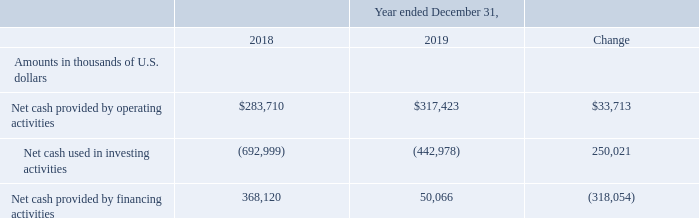Cash Flows
Year ended December 31, 2018 compared to the year ended December 31, 2019
The following table summarizes our net cash flows from operating, investing and financing activities for the years indicated:
Net Cash Provided By Operating Activities
Net cash provided by operating activities increased by $33.7 million, from $283.7 million during the year ended December 31, 2018 to $317.4 million during the year ended December 31, 2019. The increase was attributable to an increase of $57.7 million caused by movements in working capital accounts due primarily to (a) increased cash from related parties of $56.3 million (mainly collection of Cool Pool receivables), (b) an increase of $20.3 million from movements in other payables and accruals, and (c) an increase of $4.6 million from movements in trade and other receivables, partially offset by an increase in cash collateral on swaps of $22.2 million, an increase of $28.2 million in total revenues (revenues and net pool allocation), partially offset by a decrease of $29.9 million in cash paid for interest including the interest paid for finance leases and a net decrease of $22.3 million from the remaining movements.
Net Cash Used In Investing Activities
Net cash used in investing activities decreased by $250.0 million, from $693.0 million during the year ended December 31, 2018 to $443.0 million during the year ended December 31, 2019. The decrease is attributable to a decrease of $203.7 million in net cash used in payments for the construction costs of newbuildings and other fixed assets, a net increase of $45.5 million in cash from short-term investments in the year ended December 31, 2019, compared to the same period of 2018 and an increase of $0.8 million in cash from interest income.
Net Cash Provided By Financing Activities
Net cash provided by financing activities decreased by $318.0 million, from $368.1 million during the year ended December 31, 2018 to $50.1 million during the year ended December 31, 2019. The decrease is mainly attributable to an increase of $316.0 million in bank loan repayments, a decrease of $208.4 million in proceeds from the GasLog Partners’ issuance of preference units, a decrease of $60.4 million in proceeds from the GasLog Partners’ common unit offerings, an increase of $46.7 million in payments for NOK bond repurchase at a premium, an increase of $26.6 million in cash used for purchases of treasury shares or common units of GasLog Partners, an increase of $18.5 million in payments of loan issuance costs, an increase of $15.4 million in dividend payments on common and preference shares, an increase of $3.7 million in payments for cross currency swaps’ termination, an increase of $2.6 million in payments for lease liabilities, an increase of $0.8 million in payments for equity-related costs and a decrease of $0.5 million in proceeds from stock option exercise, partially offset by an increase of $381.6 million in proceeds from borrowings.
What are the components of net cash flows recorded? Operating activities, investing activities, financing activities. What was the reason for the decrease in net cash used in investing activites? The decrease is attributable to a decrease of $203.7 million in net cash used in payments for the construction costs of newbuildings and other fixed assets, a net increase of $45.5 million in cash from short-term investments in the year ended december 31, 2019, compared to the same period of 2018 and an increase of $0.8 million in cash from interest income. By how much did the bank loan repayment change? Increase of $316.0 million. Which year was the net cash provided by operating activities higher? $317,423 > $283,710
Answer: 2019. What was the percentage change in net cash provided by operating activities from 2018 to 2019?
Answer scale should be: percent. ($317,423- $283,710)/$283,710 
Answer: 11.88. What was the percentage change in net cash provided by financing activities from 2018 to 2019?
Answer scale should be: percent. (50,066 - 368,120)/368,120 
Answer: -86.4. 